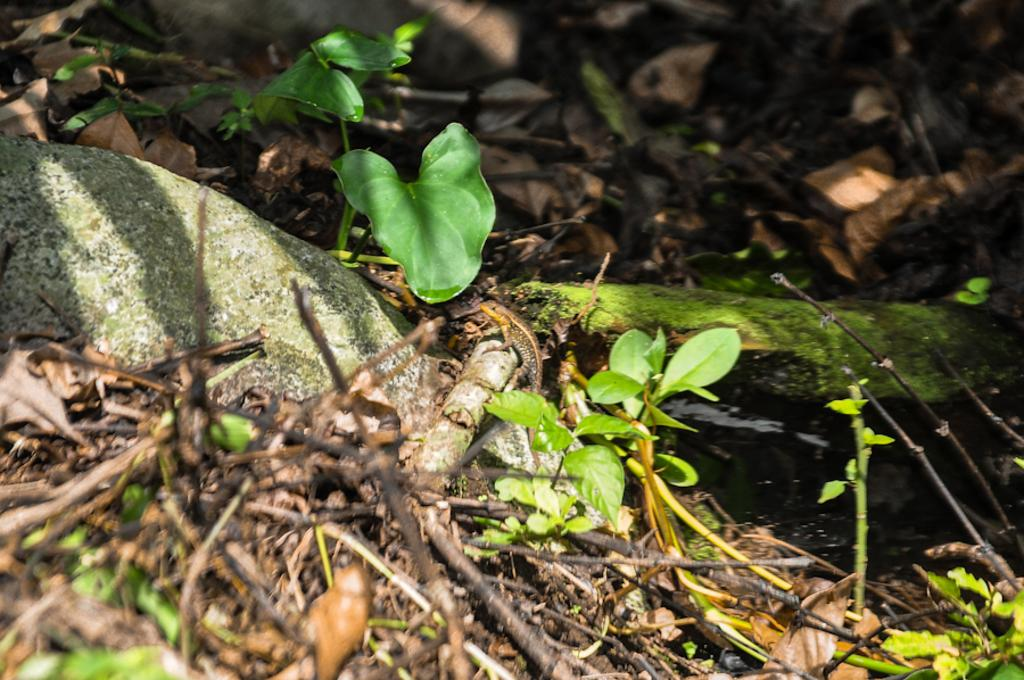What type of vegetation is present in the image? There are green leaves in the image. Are there any fallen leaves visible in the image? Yes, there are dried leaves in the image. What type of organic growth can be seen in the image? There is algae in the image. What type of material is present in the image? There are wooden sticks in the image. What type of quilt is being used to cover the algae in the image? There is no quilt present in the image, and the algae is not covered. How many plates are visible in the image? There are no plates present in the image. 